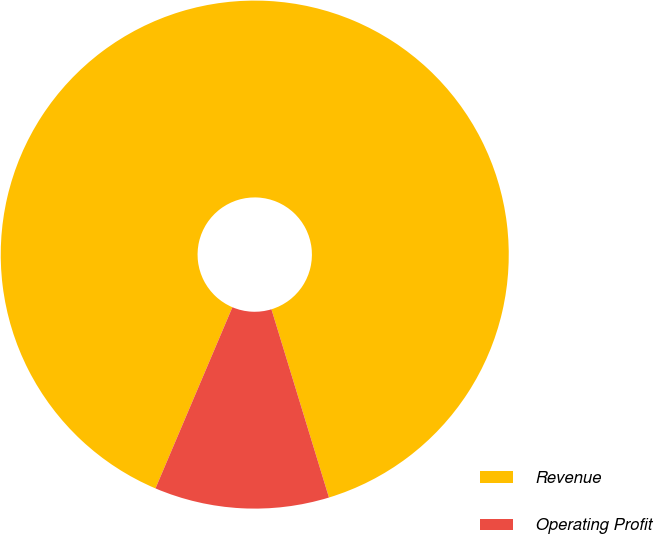Convert chart. <chart><loc_0><loc_0><loc_500><loc_500><pie_chart><fcel>Revenue<fcel>Operating Profit<nl><fcel>88.89%<fcel>11.11%<nl></chart> 